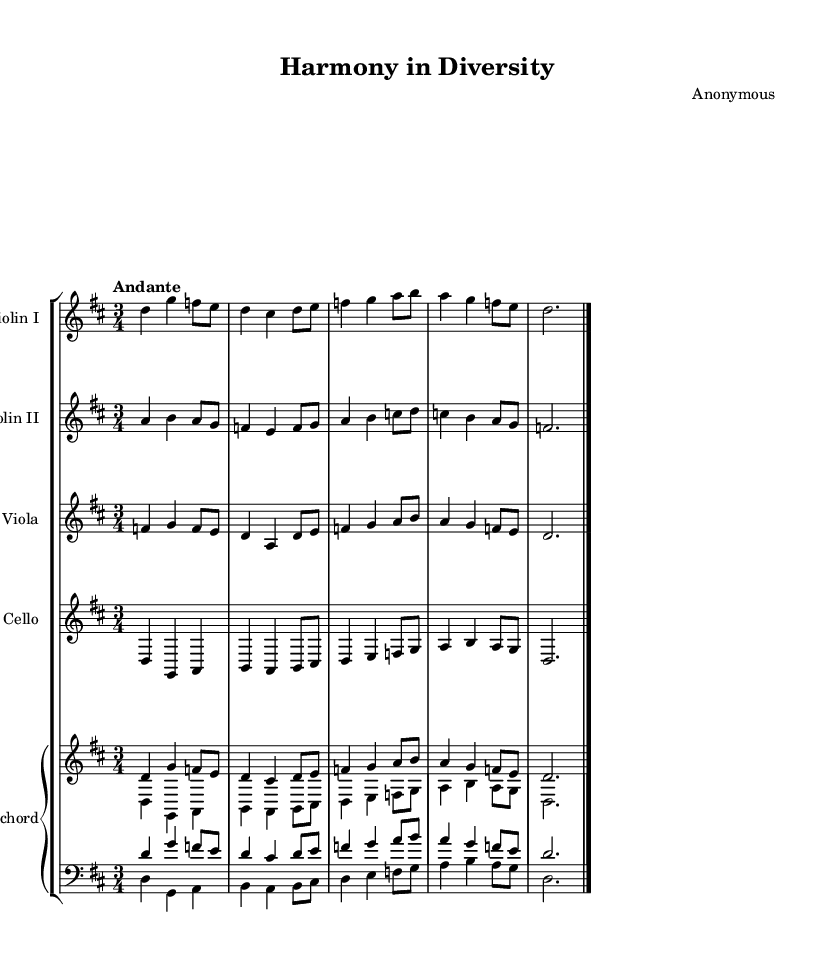what is the key signature of this music? The key signature indicated by the notation shows two sharps, which correspond to the notes F# and C#. This is characteristic of D major.
Answer: D major what is the time signature of this music? The time signature is represented as 3/4, which means there are three beats in each measure, and the quarter note gets one beat.
Answer: 3/4 what is the tempo marking of this music? The tempo marking is indicated as "Andante," suggesting a moderate pace, typically around 76-108 beats per minute.
Answer: Andante how many instruments are featured in this piece? By examining the score, there are five distinct parts: Violin I, Violin II, Viola, Cello, and Harpsichord. This indicates a total of four instrumental different voices.
Answer: Five what is the texture of this Baroque composition? The texture can be determined by looking at the combination of the instruments and how they are arranged. The piece features a melody accompanied by a harmonic structure typical of Baroque music, suggesting a polyphonic texture.
Answer: Polyphonic which instruments are performing the lowest range in this piece? The cello part is the lowest in range, followed closely by the lower staff of the harpsichord. By analyzing the written notes, it's clear that the cello plays bass notes that provide the harmonic foundation in the low range.
Answer: Cello 